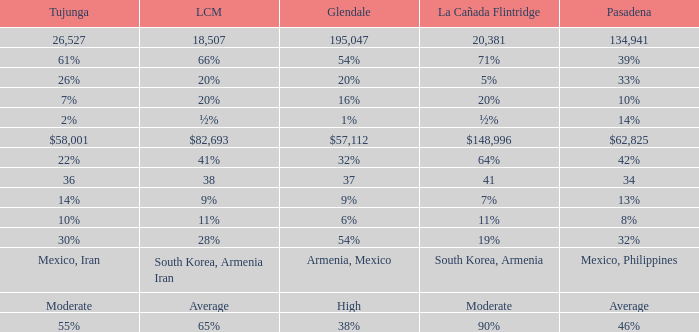What is the figure for La Crescenta-Montrose when Gelndale is $57,112? $82,693. 